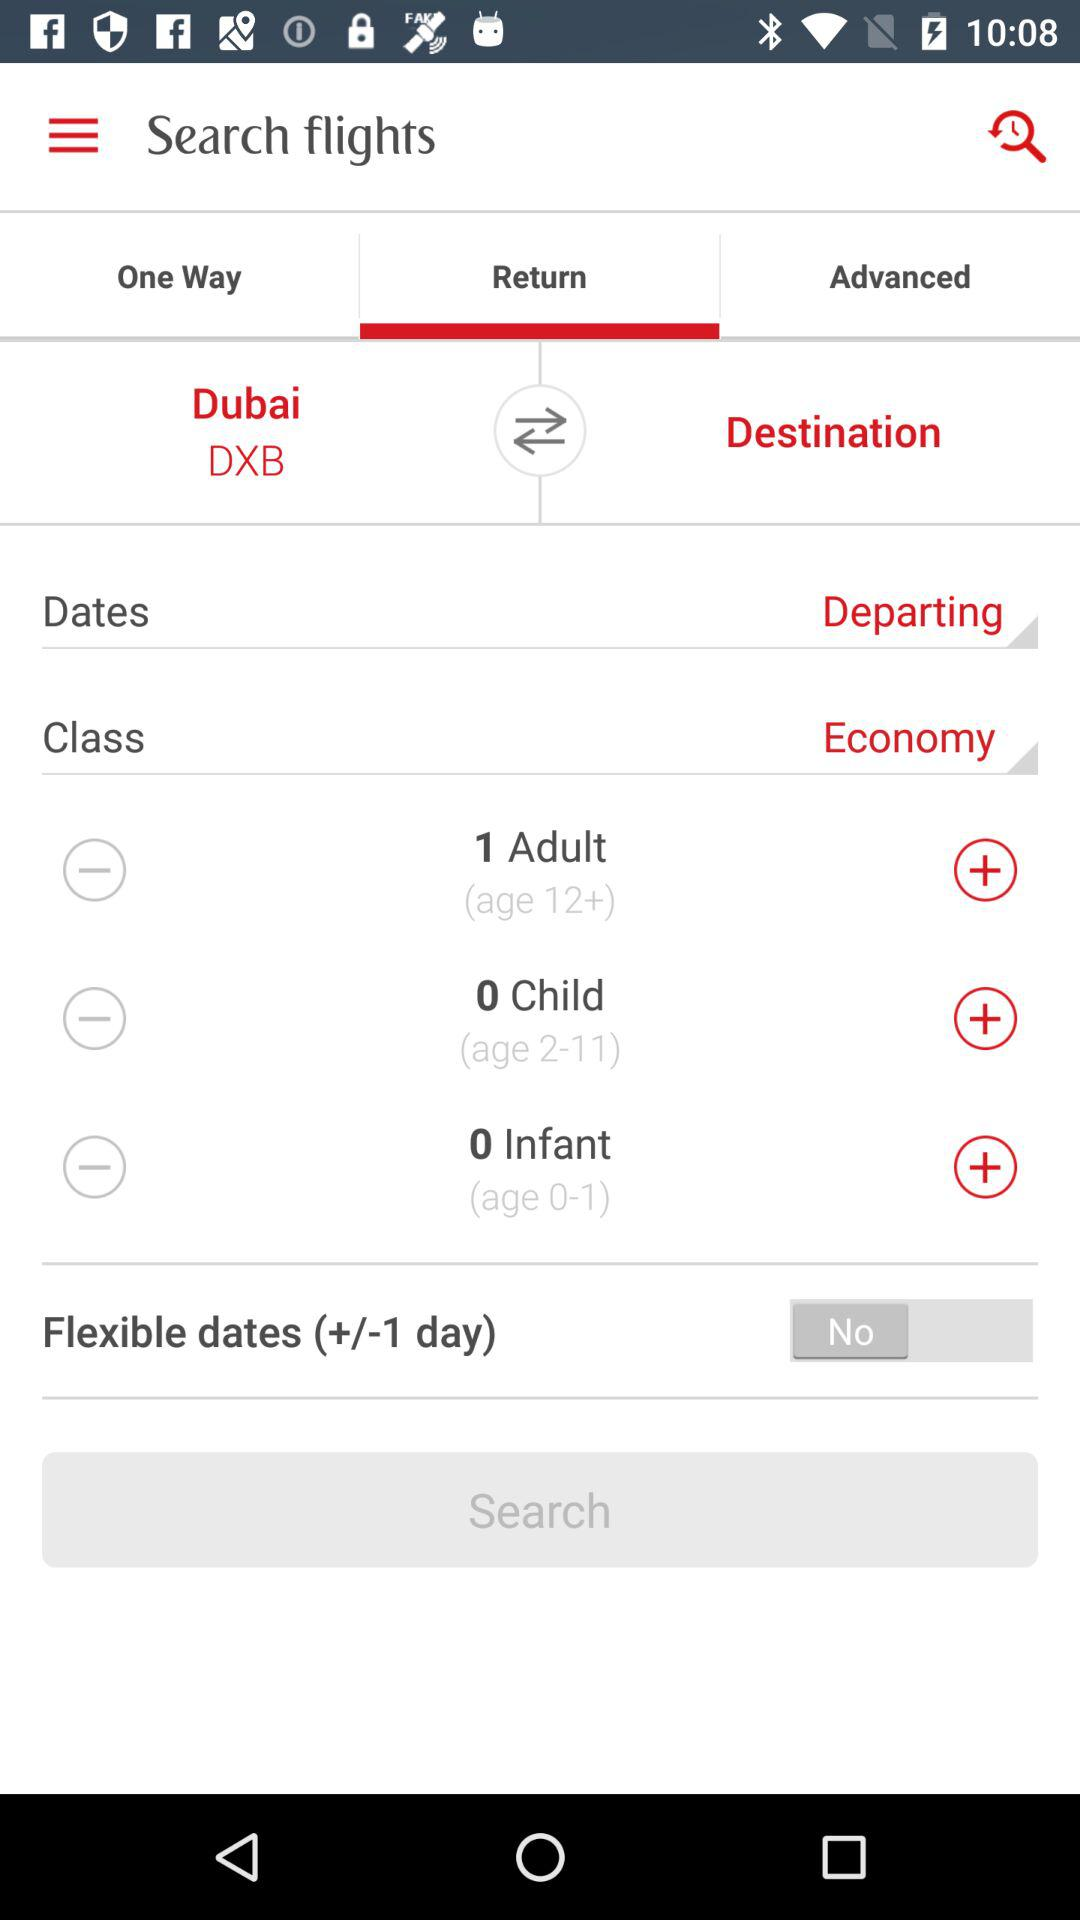How many adults are flying?
Answer the question using a single word or phrase. 1 